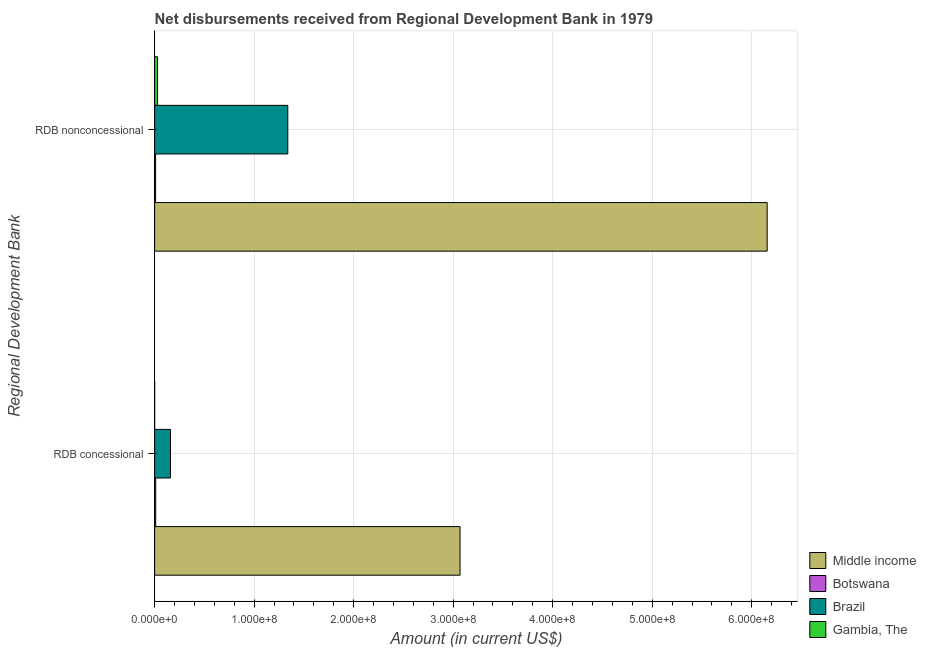How many groups of bars are there?
Provide a succinct answer. 2. Are the number of bars per tick equal to the number of legend labels?
Give a very brief answer. Yes. Are the number of bars on each tick of the Y-axis equal?
Provide a succinct answer. Yes. What is the label of the 2nd group of bars from the top?
Your response must be concise. RDB concessional. What is the net non concessional disbursements from rdb in Gambia, The?
Your answer should be very brief. 2.94e+06. Across all countries, what is the maximum net concessional disbursements from rdb?
Make the answer very short. 3.07e+08. Across all countries, what is the minimum net concessional disbursements from rdb?
Ensure brevity in your answer.  7.40e+04. In which country was the net non concessional disbursements from rdb minimum?
Ensure brevity in your answer.  Botswana. What is the total net non concessional disbursements from rdb in the graph?
Keep it short and to the point. 7.53e+08. What is the difference between the net non concessional disbursements from rdb in Gambia, The and that in Middle income?
Keep it short and to the point. -6.13e+08. What is the difference between the net concessional disbursements from rdb in Gambia, The and the net non concessional disbursements from rdb in Middle income?
Make the answer very short. -6.15e+08. What is the average net concessional disbursements from rdb per country?
Ensure brevity in your answer.  8.10e+07. What is the difference between the net non concessional disbursements from rdb and net concessional disbursements from rdb in Gambia, The?
Make the answer very short. 2.86e+06. In how many countries, is the net non concessional disbursements from rdb greater than 240000000 US$?
Keep it short and to the point. 1. What is the ratio of the net concessional disbursements from rdb in Middle income to that in Brazil?
Make the answer very short. 19.22. Is the net concessional disbursements from rdb in Gambia, The less than that in Brazil?
Your response must be concise. Yes. In how many countries, is the net concessional disbursements from rdb greater than the average net concessional disbursements from rdb taken over all countries?
Make the answer very short. 1. What does the 3rd bar from the top in RDB concessional represents?
Your answer should be compact. Botswana. Are all the bars in the graph horizontal?
Provide a short and direct response. Yes. How many countries are there in the graph?
Make the answer very short. 4. What is the difference between two consecutive major ticks on the X-axis?
Make the answer very short. 1.00e+08. Where does the legend appear in the graph?
Give a very brief answer. Bottom right. What is the title of the graph?
Your answer should be very brief. Net disbursements received from Regional Development Bank in 1979. Does "Belgium" appear as one of the legend labels in the graph?
Your answer should be compact. No. What is the label or title of the X-axis?
Provide a succinct answer. Amount (in current US$). What is the label or title of the Y-axis?
Your response must be concise. Regional Development Bank. What is the Amount (in current US$) in Middle income in RDB concessional?
Provide a short and direct response. 3.07e+08. What is the Amount (in current US$) of Botswana in RDB concessional?
Your response must be concise. 1.11e+06. What is the Amount (in current US$) of Brazil in RDB concessional?
Your response must be concise. 1.60e+07. What is the Amount (in current US$) of Gambia, The in RDB concessional?
Provide a short and direct response. 7.40e+04. What is the Amount (in current US$) in Middle income in RDB nonconcessional?
Your answer should be compact. 6.16e+08. What is the Amount (in current US$) of Botswana in RDB nonconcessional?
Offer a terse response. 9.93e+05. What is the Amount (in current US$) in Brazil in RDB nonconcessional?
Give a very brief answer. 1.34e+08. What is the Amount (in current US$) of Gambia, The in RDB nonconcessional?
Make the answer very short. 2.94e+06. Across all Regional Development Bank, what is the maximum Amount (in current US$) in Middle income?
Your answer should be compact. 6.16e+08. Across all Regional Development Bank, what is the maximum Amount (in current US$) in Botswana?
Your answer should be very brief. 1.11e+06. Across all Regional Development Bank, what is the maximum Amount (in current US$) in Brazil?
Give a very brief answer. 1.34e+08. Across all Regional Development Bank, what is the maximum Amount (in current US$) in Gambia, The?
Keep it short and to the point. 2.94e+06. Across all Regional Development Bank, what is the minimum Amount (in current US$) of Middle income?
Your answer should be compact. 3.07e+08. Across all Regional Development Bank, what is the minimum Amount (in current US$) of Botswana?
Your response must be concise. 9.93e+05. Across all Regional Development Bank, what is the minimum Amount (in current US$) of Brazil?
Your answer should be compact. 1.60e+07. Across all Regional Development Bank, what is the minimum Amount (in current US$) in Gambia, The?
Your answer should be compact. 7.40e+04. What is the total Amount (in current US$) in Middle income in the graph?
Offer a terse response. 9.22e+08. What is the total Amount (in current US$) of Botswana in the graph?
Keep it short and to the point. 2.10e+06. What is the total Amount (in current US$) in Brazil in the graph?
Your response must be concise. 1.50e+08. What is the total Amount (in current US$) in Gambia, The in the graph?
Offer a very short reply. 3.01e+06. What is the difference between the Amount (in current US$) of Middle income in RDB concessional and that in RDB nonconcessional?
Provide a short and direct response. -3.09e+08. What is the difference between the Amount (in current US$) in Botswana in RDB concessional and that in RDB nonconcessional?
Provide a succinct answer. 1.17e+05. What is the difference between the Amount (in current US$) in Brazil in RDB concessional and that in RDB nonconcessional?
Offer a terse response. -1.18e+08. What is the difference between the Amount (in current US$) of Gambia, The in RDB concessional and that in RDB nonconcessional?
Your response must be concise. -2.86e+06. What is the difference between the Amount (in current US$) in Middle income in RDB concessional and the Amount (in current US$) in Botswana in RDB nonconcessional?
Provide a succinct answer. 3.06e+08. What is the difference between the Amount (in current US$) of Middle income in RDB concessional and the Amount (in current US$) of Brazil in RDB nonconcessional?
Provide a succinct answer. 1.73e+08. What is the difference between the Amount (in current US$) of Middle income in RDB concessional and the Amount (in current US$) of Gambia, The in RDB nonconcessional?
Ensure brevity in your answer.  3.04e+08. What is the difference between the Amount (in current US$) in Botswana in RDB concessional and the Amount (in current US$) in Brazil in RDB nonconcessional?
Keep it short and to the point. -1.33e+08. What is the difference between the Amount (in current US$) in Botswana in RDB concessional and the Amount (in current US$) in Gambia, The in RDB nonconcessional?
Give a very brief answer. -1.83e+06. What is the difference between the Amount (in current US$) of Brazil in RDB concessional and the Amount (in current US$) of Gambia, The in RDB nonconcessional?
Your answer should be compact. 1.30e+07. What is the average Amount (in current US$) in Middle income per Regional Development Bank?
Offer a terse response. 4.61e+08. What is the average Amount (in current US$) of Botswana per Regional Development Bank?
Make the answer very short. 1.05e+06. What is the average Amount (in current US$) in Brazil per Regional Development Bank?
Keep it short and to the point. 7.49e+07. What is the average Amount (in current US$) in Gambia, The per Regional Development Bank?
Offer a very short reply. 1.50e+06. What is the difference between the Amount (in current US$) in Middle income and Amount (in current US$) in Botswana in RDB concessional?
Provide a succinct answer. 3.06e+08. What is the difference between the Amount (in current US$) of Middle income and Amount (in current US$) of Brazil in RDB concessional?
Give a very brief answer. 2.91e+08. What is the difference between the Amount (in current US$) in Middle income and Amount (in current US$) in Gambia, The in RDB concessional?
Offer a very short reply. 3.07e+08. What is the difference between the Amount (in current US$) in Botswana and Amount (in current US$) in Brazil in RDB concessional?
Ensure brevity in your answer.  -1.49e+07. What is the difference between the Amount (in current US$) in Botswana and Amount (in current US$) in Gambia, The in RDB concessional?
Your answer should be very brief. 1.04e+06. What is the difference between the Amount (in current US$) in Brazil and Amount (in current US$) in Gambia, The in RDB concessional?
Your response must be concise. 1.59e+07. What is the difference between the Amount (in current US$) in Middle income and Amount (in current US$) in Botswana in RDB nonconcessional?
Make the answer very short. 6.15e+08. What is the difference between the Amount (in current US$) of Middle income and Amount (in current US$) of Brazil in RDB nonconcessional?
Provide a succinct answer. 4.82e+08. What is the difference between the Amount (in current US$) in Middle income and Amount (in current US$) in Gambia, The in RDB nonconcessional?
Ensure brevity in your answer.  6.13e+08. What is the difference between the Amount (in current US$) in Botswana and Amount (in current US$) in Brazil in RDB nonconcessional?
Give a very brief answer. -1.33e+08. What is the difference between the Amount (in current US$) in Botswana and Amount (in current US$) in Gambia, The in RDB nonconcessional?
Make the answer very short. -1.94e+06. What is the difference between the Amount (in current US$) of Brazil and Amount (in current US$) of Gambia, The in RDB nonconcessional?
Provide a succinct answer. 1.31e+08. What is the ratio of the Amount (in current US$) in Middle income in RDB concessional to that in RDB nonconcessional?
Keep it short and to the point. 0.5. What is the ratio of the Amount (in current US$) of Botswana in RDB concessional to that in RDB nonconcessional?
Make the answer very short. 1.12. What is the ratio of the Amount (in current US$) of Brazil in RDB concessional to that in RDB nonconcessional?
Offer a very short reply. 0.12. What is the ratio of the Amount (in current US$) in Gambia, The in RDB concessional to that in RDB nonconcessional?
Offer a terse response. 0.03. What is the difference between the highest and the second highest Amount (in current US$) of Middle income?
Provide a succinct answer. 3.09e+08. What is the difference between the highest and the second highest Amount (in current US$) in Botswana?
Give a very brief answer. 1.17e+05. What is the difference between the highest and the second highest Amount (in current US$) in Brazil?
Ensure brevity in your answer.  1.18e+08. What is the difference between the highest and the second highest Amount (in current US$) of Gambia, The?
Your response must be concise. 2.86e+06. What is the difference between the highest and the lowest Amount (in current US$) in Middle income?
Make the answer very short. 3.09e+08. What is the difference between the highest and the lowest Amount (in current US$) in Botswana?
Your answer should be compact. 1.17e+05. What is the difference between the highest and the lowest Amount (in current US$) in Brazil?
Provide a short and direct response. 1.18e+08. What is the difference between the highest and the lowest Amount (in current US$) in Gambia, The?
Provide a succinct answer. 2.86e+06. 